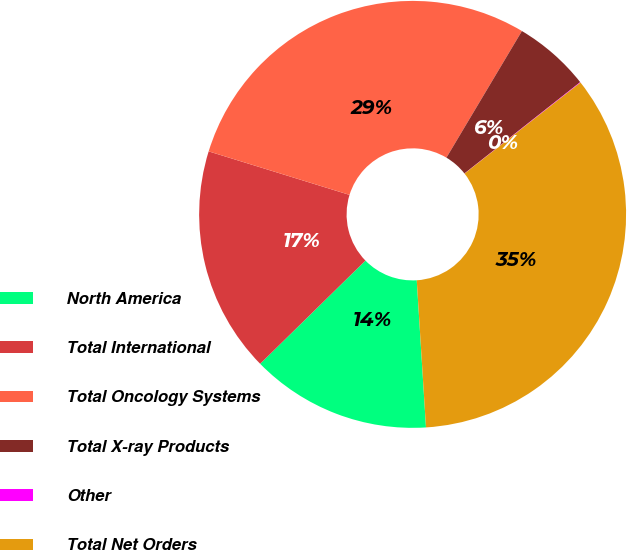Convert chart to OTSL. <chart><loc_0><loc_0><loc_500><loc_500><pie_chart><fcel>North America<fcel>Total International<fcel>Total Oncology Systems<fcel>Total X-ray Products<fcel>Other<fcel>Total Net Orders<nl><fcel>13.66%<fcel>17.11%<fcel>28.79%<fcel>5.81%<fcel>0.04%<fcel>34.6%<nl></chart> 